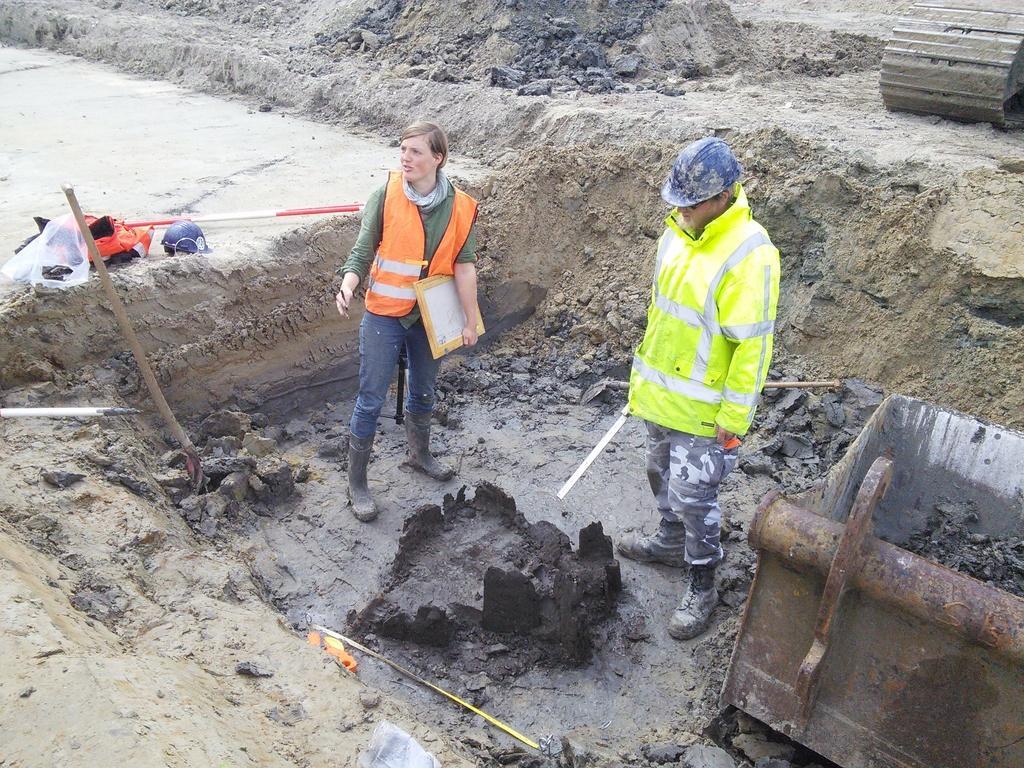Could you give a brief overview of what you see in this image? There is a lady wearing a jacket and boots is holding something in the hand. Also there is a person wearing jacket and helmet is standing. Near to him there is a box. There are stones on the ground. Near to the lady there is a helmet and some other things. 